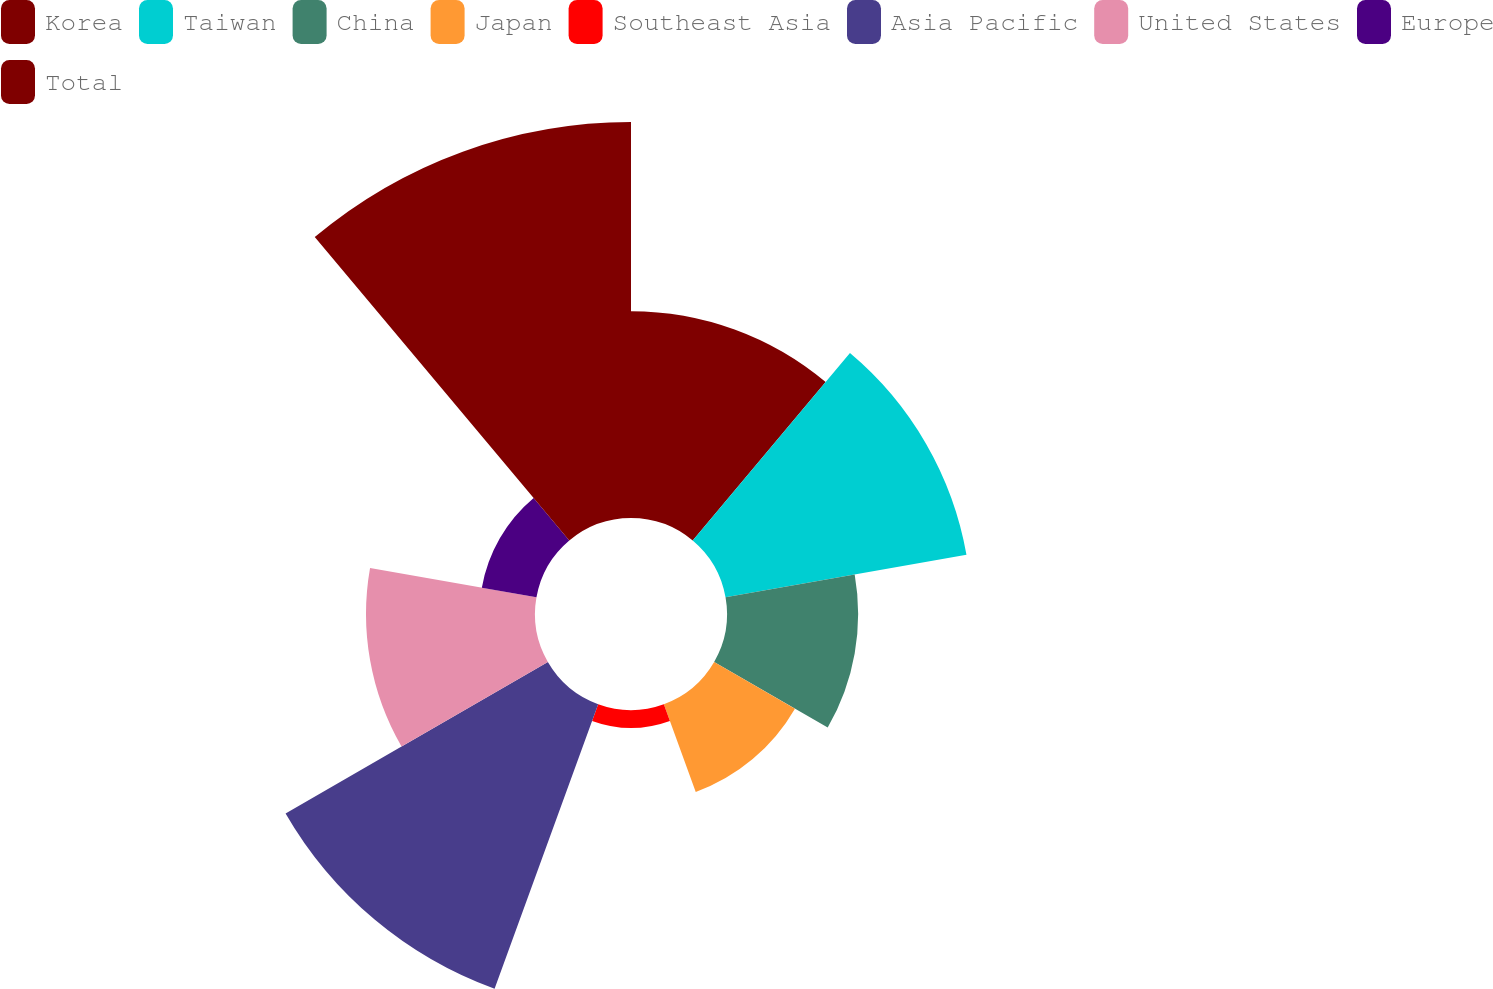Convert chart. <chart><loc_0><loc_0><loc_500><loc_500><pie_chart><fcel>Korea<fcel>Taiwan<fcel>China<fcel>Japan<fcel>Southeast Asia<fcel>Asia Pacific<fcel>United States<fcel>Europe<fcel>Total<nl><fcel>12.79%<fcel>15.13%<fcel>8.11%<fcel>5.77%<fcel>1.1%<fcel>18.73%<fcel>10.45%<fcel>3.43%<fcel>24.49%<nl></chart> 